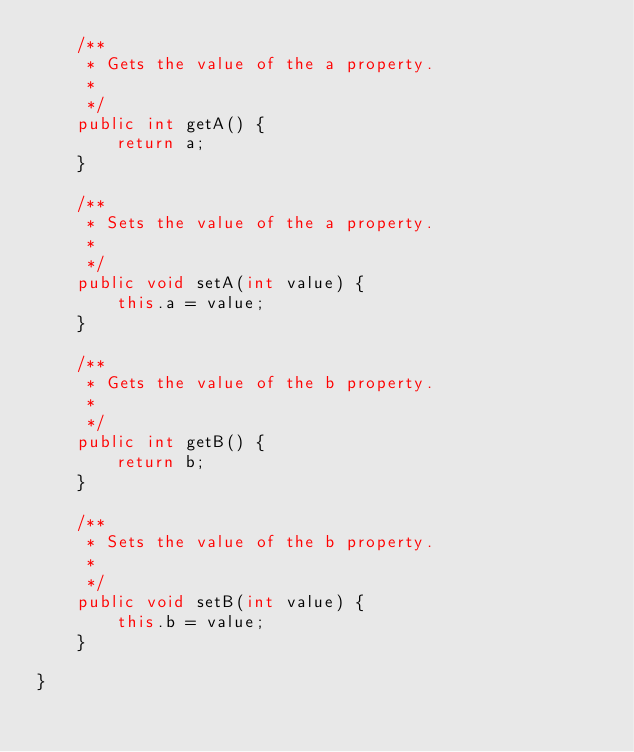Convert code to text. <code><loc_0><loc_0><loc_500><loc_500><_Java_>    /**
     * Gets the value of the a property.
     * 
     */
    public int getA() {
        return a;
    }

    /**
     * Sets the value of the a property.
     * 
     */
    public void setA(int value) {
        this.a = value;
    }

    /**
     * Gets the value of the b property.
     * 
     */
    public int getB() {
        return b;
    }

    /**
     * Sets the value of the b property.
     * 
     */
    public void setB(int value) {
        this.b = value;
    }

}
</code> 